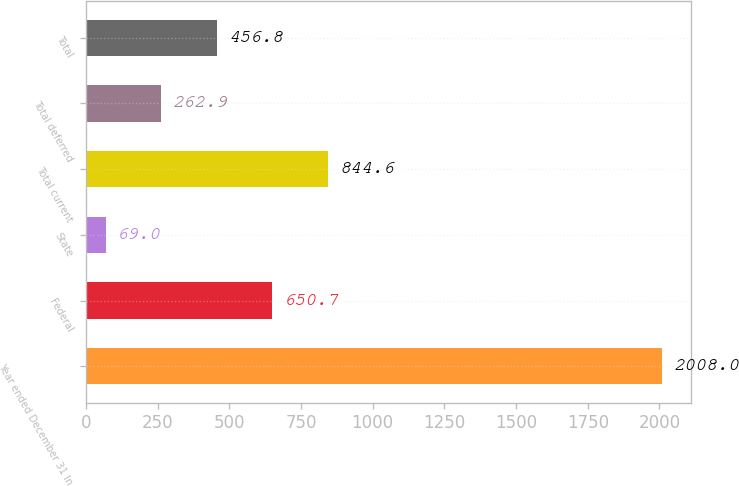Convert chart. <chart><loc_0><loc_0><loc_500><loc_500><bar_chart><fcel>Year ended December 31 In<fcel>Federal<fcel>State<fcel>Total current<fcel>Total deferred<fcel>Total<nl><fcel>2008<fcel>650.7<fcel>69<fcel>844.6<fcel>262.9<fcel>456.8<nl></chart> 